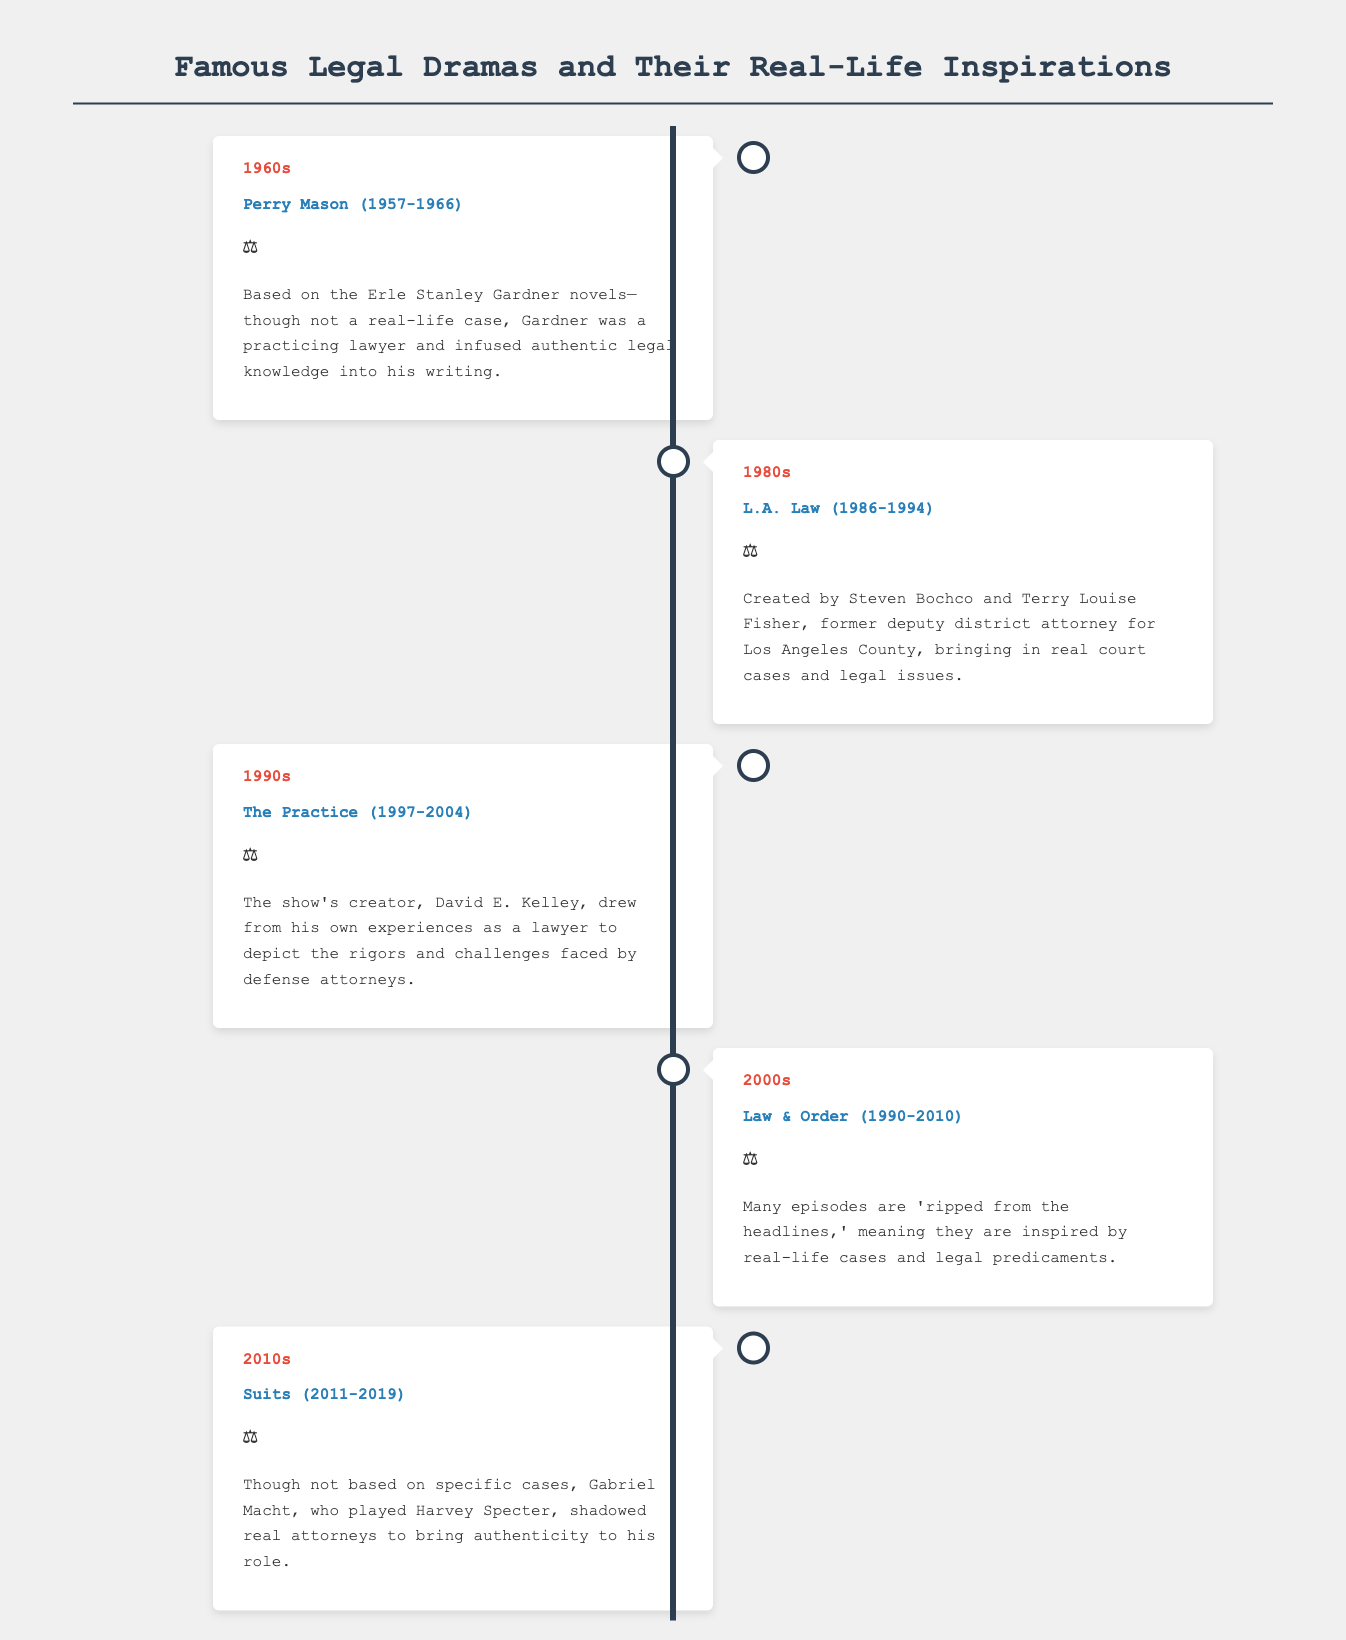What decade did Perry Mason air? Perry Mason aired from 1957 to 1966, which falls into the 1960s decade.
Answer: 1960s Which show is known for being 'ripped from the headlines'? The phrase 'ripped from the headlines' is commonly associated with Law & Order, which is highlighted as inspired by real-life cases.
Answer: Law & Order Who created The Practice? The Practice was created by David E. Kelley, as noted in the document.
Answer: David E. Kelley What did Gabriel Macht do to add authenticity to his role in Suits? Gabriel Macht shadowed real attorneys to bring authenticity to his portrayal in Suits.
Answer: Shadowed real attorneys In which decade did L.A. Law premiere? L.A. Law premiered in the 1980s, according to the timeline provided.
Answer: 1980s 